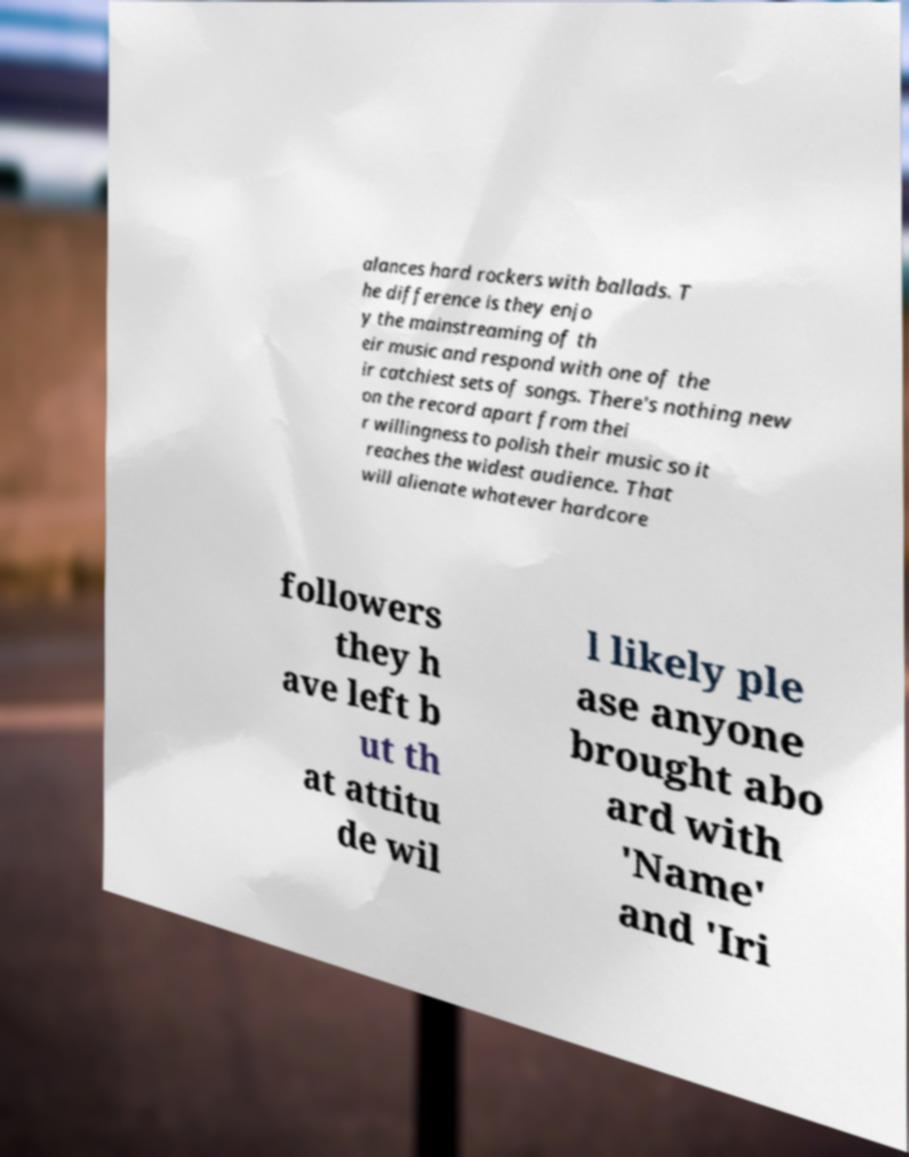Please identify and transcribe the text found in this image. alances hard rockers with ballads. T he difference is they enjo y the mainstreaming of th eir music and respond with one of the ir catchiest sets of songs. There's nothing new on the record apart from thei r willingness to polish their music so it reaches the widest audience. That will alienate whatever hardcore followers they h ave left b ut th at attitu de wil l likely ple ase anyone brought abo ard with 'Name' and 'Iri 